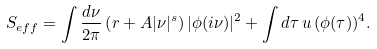Convert formula to latex. <formula><loc_0><loc_0><loc_500><loc_500>S _ { e f f } = \int \frac { d \nu } { 2 \pi } \left ( r + A | \nu | ^ { s } \right ) | \phi ( i \nu ) | ^ { 2 } + \int d \tau \, u \, ( \phi ( \tau ) ) ^ { 4 } .</formula> 